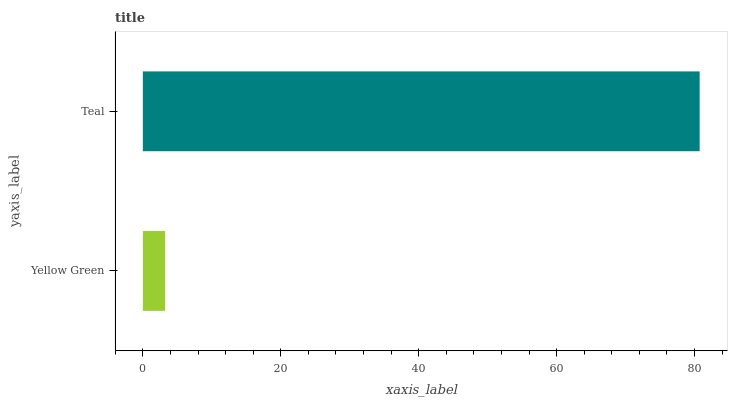Is Yellow Green the minimum?
Answer yes or no. Yes. Is Teal the maximum?
Answer yes or no. Yes. Is Teal the minimum?
Answer yes or no. No. Is Teal greater than Yellow Green?
Answer yes or no. Yes. Is Yellow Green less than Teal?
Answer yes or no. Yes. Is Yellow Green greater than Teal?
Answer yes or no. No. Is Teal less than Yellow Green?
Answer yes or no. No. Is Teal the high median?
Answer yes or no. Yes. Is Yellow Green the low median?
Answer yes or no. Yes. Is Yellow Green the high median?
Answer yes or no. No. Is Teal the low median?
Answer yes or no. No. 